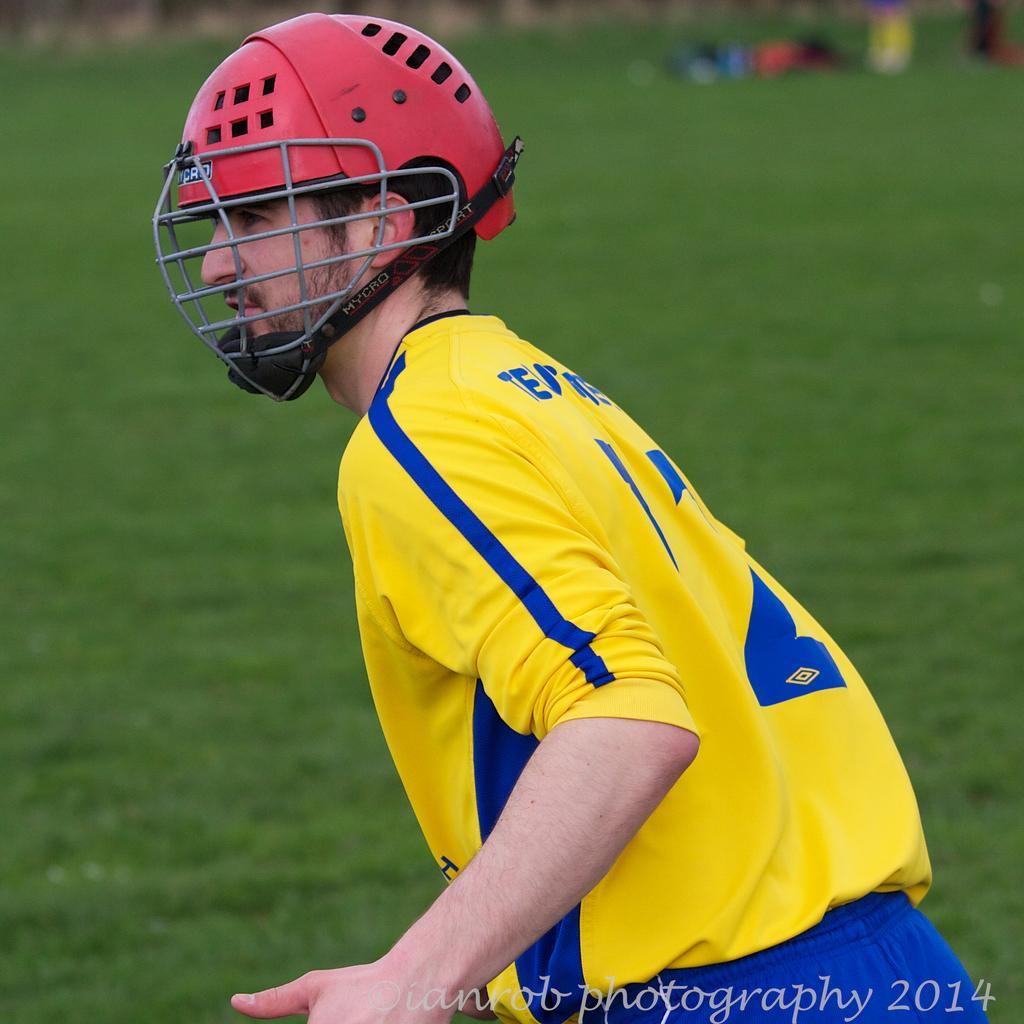Could you give a brief overview of what you see in this image? In the image we can see the close up image of the person wearing clothes and helmet. Here we can see the grass and the background is slightly blurred. On the bottom right we can see the watermark. 